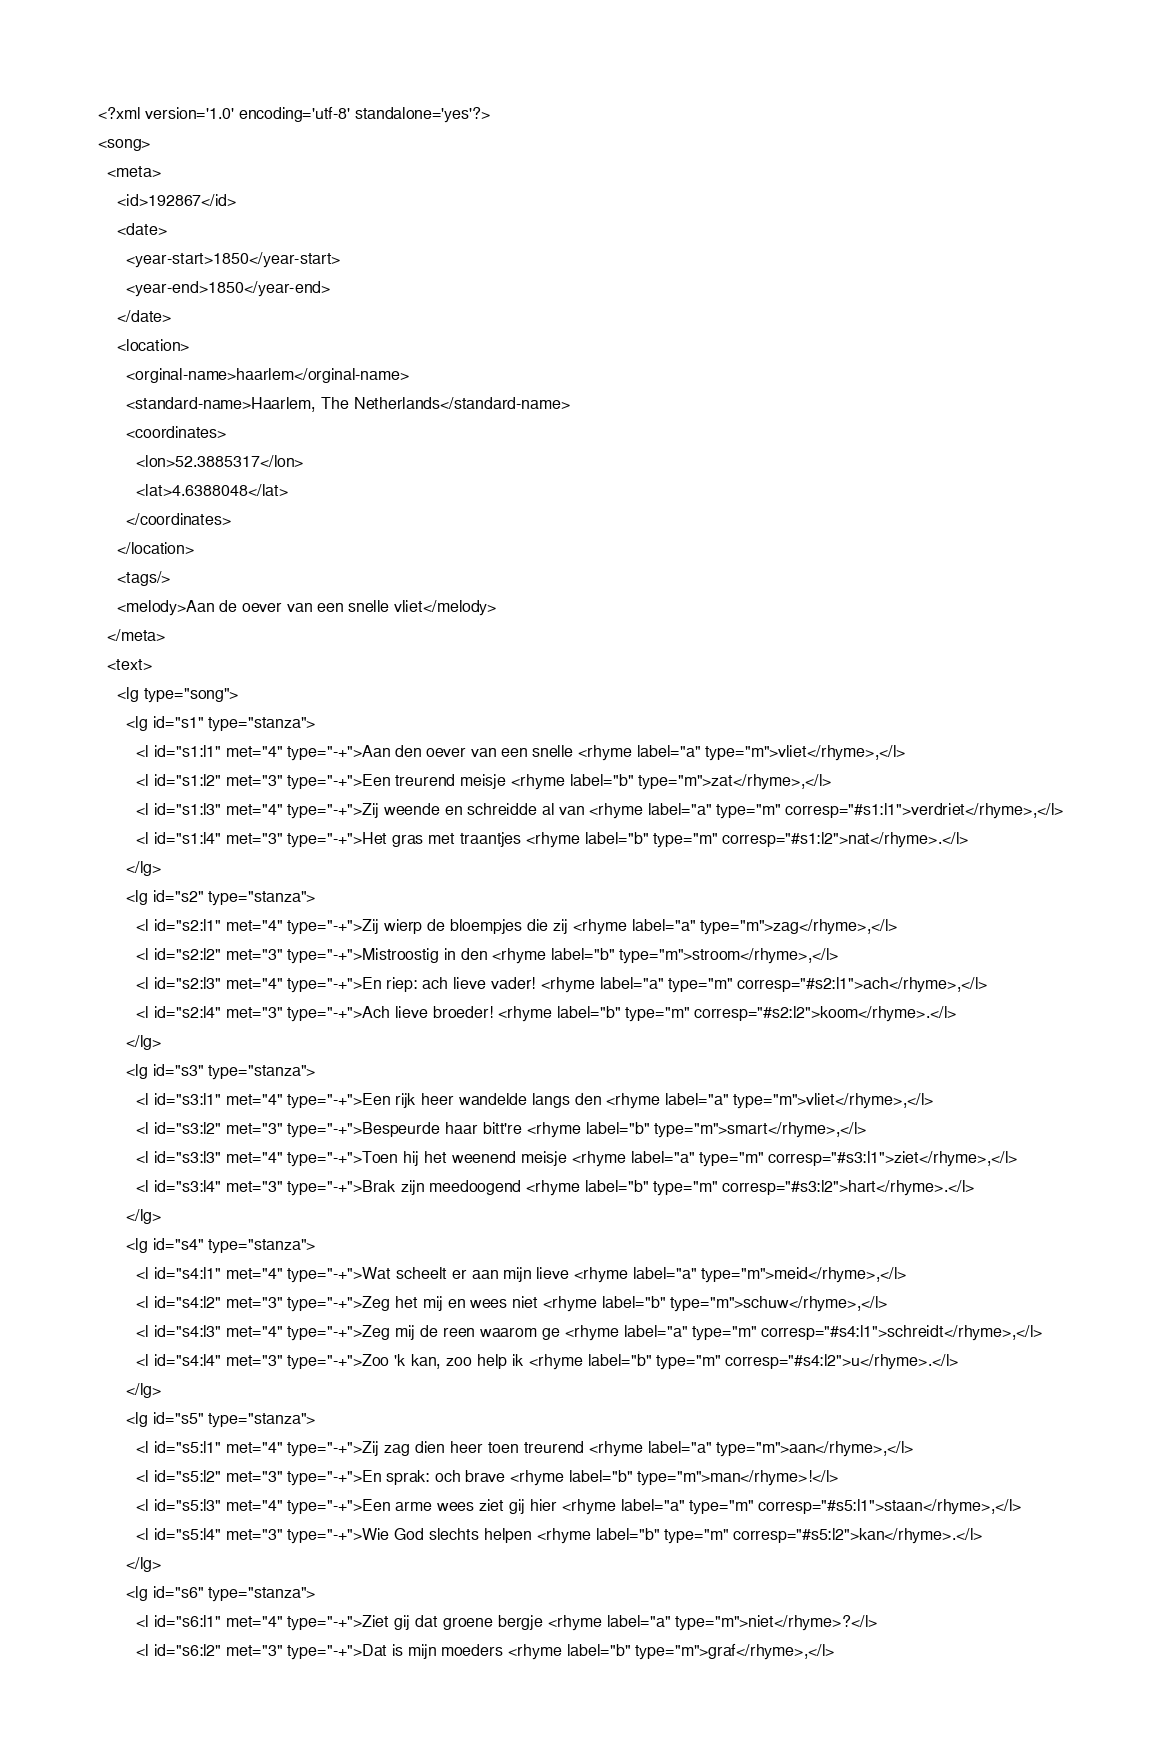Convert code to text. <code><loc_0><loc_0><loc_500><loc_500><_XML_><?xml version='1.0' encoding='utf-8' standalone='yes'?>
<song>
  <meta>
    <id>192867</id>
    <date>
      <year-start>1850</year-start>
      <year-end>1850</year-end>
    </date>
    <location>
      <orginal-name>haarlem</orginal-name>
      <standard-name>Haarlem, The Netherlands</standard-name>
      <coordinates>
        <lon>52.3885317</lon>
        <lat>4.6388048</lat>
      </coordinates>
    </location>
    <tags/>
    <melody>Aan de oever van een snelle vliet</melody>
  </meta>
  <text>
    <lg type="song">
      <lg id="s1" type="stanza">
        <l id="s1:l1" met="4" type="-+">Aan den oever van een snelle <rhyme label="a" type="m">vliet</rhyme>,</l>
        <l id="s1:l2" met="3" type="-+">Een treurend meisje <rhyme label="b" type="m">zat</rhyme>,</l>
        <l id="s1:l3" met="4" type="-+">Zij weende en schreidde al van <rhyme label="a" type="m" corresp="#s1:l1">verdriet</rhyme>,</l>
        <l id="s1:l4" met="3" type="-+">Het gras met traantjes <rhyme label="b" type="m" corresp="#s1:l2">nat</rhyme>.</l>
      </lg>
      <lg id="s2" type="stanza">
        <l id="s2:l1" met="4" type="-+">Zij wierp de bloempjes die zij <rhyme label="a" type="m">zag</rhyme>,</l>
        <l id="s2:l2" met="3" type="-+">Mistroostig in den <rhyme label="b" type="m">stroom</rhyme>,</l>
        <l id="s2:l3" met="4" type="-+">En riep: ach lieve vader! <rhyme label="a" type="m" corresp="#s2:l1">ach</rhyme>,</l>
        <l id="s2:l4" met="3" type="-+">Ach lieve broeder! <rhyme label="b" type="m" corresp="#s2:l2">koom</rhyme>.</l>
      </lg>
      <lg id="s3" type="stanza">
        <l id="s3:l1" met="4" type="-+">Een rijk heer wandelde langs den <rhyme label="a" type="m">vliet</rhyme>,</l>
        <l id="s3:l2" met="3" type="-+">Bespeurde haar bitt're <rhyme label="b" type="m">smart</rhyme>,</l>
        <l id="s3:l3" met="4" type="-+">Toen hij het weenend meisje <rhyme label="a" type="m" corresp="#s3:l1">ziet</rhyme>,</l>
        <l id="s3:l4" met="3" type="-+">Brak zijn meedoogend <rhyme label="b" type="m" corresp="#s3:l2">hart</rhyme>.</l>
      </lg>
      <lg id="s4" type="stanza">
        <l id="s4:l1" met="4" type="-+">Wat scheelt er aan mijn lieve <rhyme label="a" type="m">meid</rhyme>,</l>
        <l id="s4:l2" met="3" type="-+">Zeg het mij en wees niet <rhyme label="b" type="m">schuw</rhyme>,</l>
        <l id="s4:l3" met="4" type="-+">Zeg mij de reen waarom ge <rhyme label="a" type="m" corresp="#s4:l1">schreidt</rhyme>,</l>
        <l id="s4:l4" met="3" type="-+">Zoo 'k kan, zoo help ik <rhyme label="b" type="m" corresp="#s4:l2">u</rhyme>.</l>
      </lg>
      <lg id="s5" type="stanza">
        <l id="s5:l1" met="4" type="-+">Zij zag dien heer toen treurend <rhyme label="a" type="m">aan</rhyme>,</l>
        <l id="s5:l2" met="3" type="-+">En sprak: och brave <rhyme label="b" type="m">man</rhyme>!</l>
        <l id="s5:l3" met="4" type="-+">Een arme wees ziet gij hier <rhyme label="a" type="m" corresp="#s5:l1">staan</rhyme>,</l>
        <l id="s5:l4" met="3" type="-+">Wie God slechts helpen <rhyme label="b" type="m" corresp="#s5:l2">kan</rhyme>.</l>
      </lg>
      <lg id="s6" type="stanza">
        <l id="s6:l1" met="4" type="-+">Ziet gij dat groene bergje <rhyme label="a" type="m">niet</rhyme>?</l>
        <l id="s6:l2" met="3" type="-+">Dat is mijn moeders <rhyme label="b" type="m">graf</rhyme>,</l></code> 